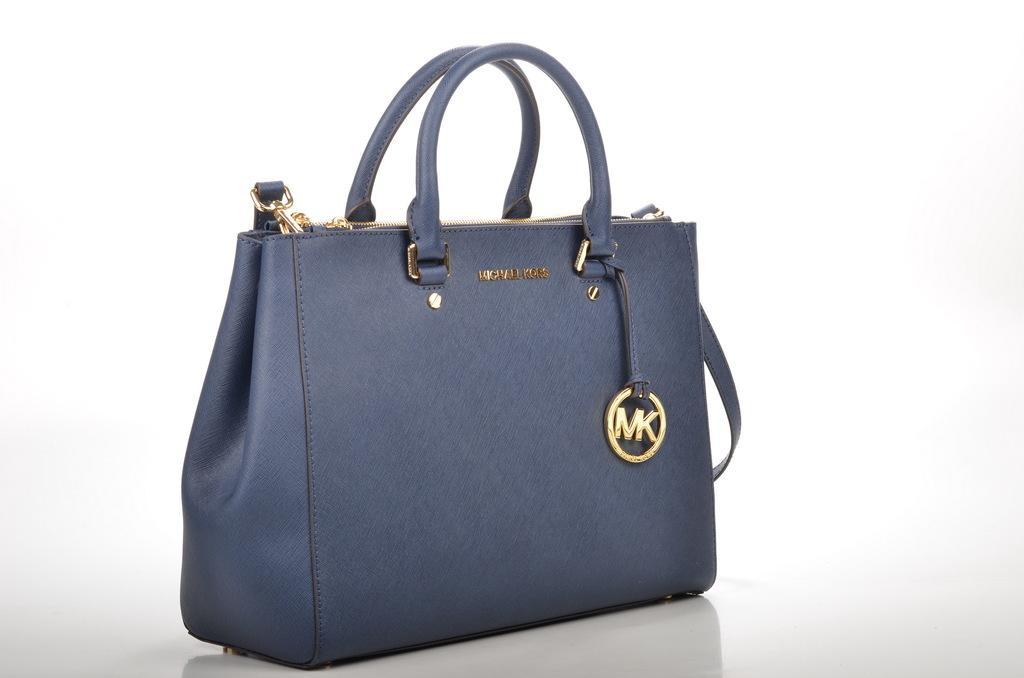What object is present in the image that can be used for carrying items? There is a bag in the image that can be used for carrying items. What color is the bag in the image? The bag is blue in color. What additional feature is attached to the bag? There is a chain on the bag. What can be seen written on the chain? The letters "MK" are written on the chain. Is there a river flowing through the bag in the image? No, there is no river present in the image, and the bag is not depicted as containing a river. 